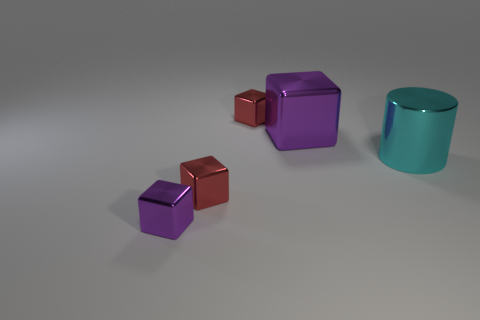What is the color of the large metallic thing that is the same shape as the tiny purple object?
Provide a short and direct response. Purple. Is there anything else that is the same shape as the large cyan thing?
Provide a short and direct response. No. Does the cyan metallic object have the same shape as the small red shiny object behind the cyan cylinder?
Offer a very short reply. No. How many other things are there of the same material as the large block?
Provide a succinct answer. 4. Does the large cylinder have the same color as the tiny cube behind the big purple object?
Provide a short and direct response. No. What is the material of the purple cube that is in front of the big cyan object?
Your response must be concise. Metal. Is there a large block that has the same color as the large cylinder?
Ensure brevity in your answer.  No. There is a metallic block that is the same size as the cyan shiny cylinder; what is its color?
Your response must be concise. Purple. What number of tiny things are either cyan cylinders or purple shiny objects?
Keep it short and to the point. 1. Are there an equal number of red shiny cubes that are on the right side of the large metal cube and metallic objects that are on the right side of the small purple block?
Provide a succinct answer. No. 